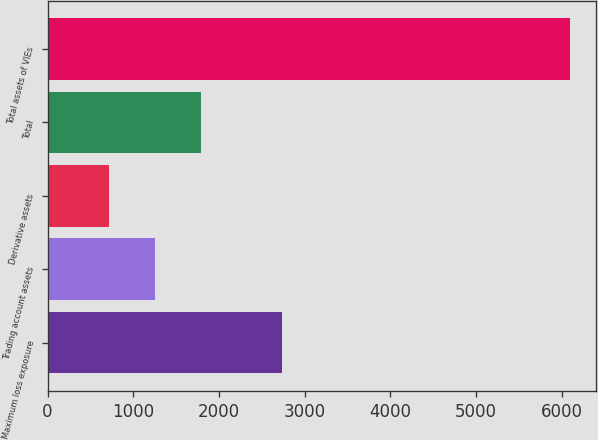Convert chart. <chart><loc_0><loc_0><loc_500><loc_500><bar_chart><fcel>Maximum loss exposure<fcel>Trading account assets<fcel>Derivative assets<fcel>Total<fcel>Total assets of VIEs<nl><fcel>2735<fcel>1258.8<fcel>722<fcel>1795.6<fcel>6090<nl></chart> 